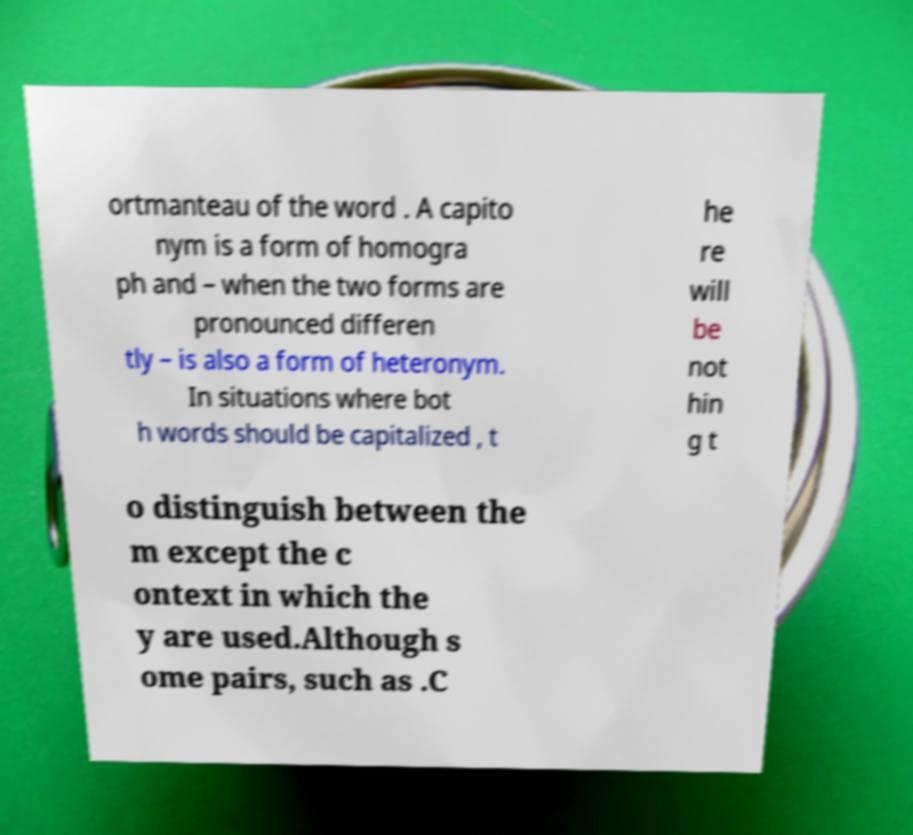I need the written content from this picture converted into text. Can you do that? ortmanteau of the word . A capito nym is a form of homogra ph and – when the two forms are pronounced differen tly – is also a form of heteronym. In situations where bot h words should be capitalized , t he re will be not hin g t o distinguish between the m except the c ontext in which the y are used.Although s ome pairs, such as .C 